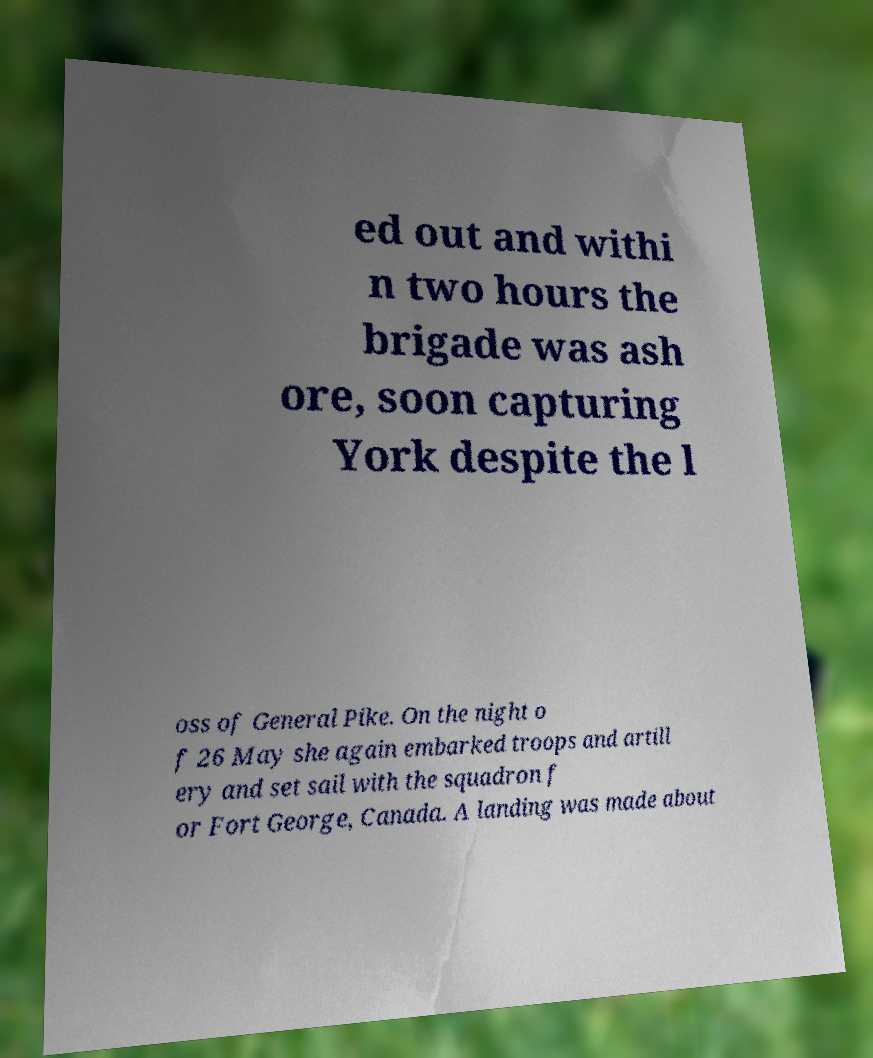There's text embedded in this image that I need extracted. Can you transcribe it verbatim? ed out and withi n two hours the brigade was ash ore, soon capturing York despite the l oss of General Pike. On the night o f 26 May she again embarked troops and artill ery and set sail with the squadron f or Fort George, Canada. A landing was made about 